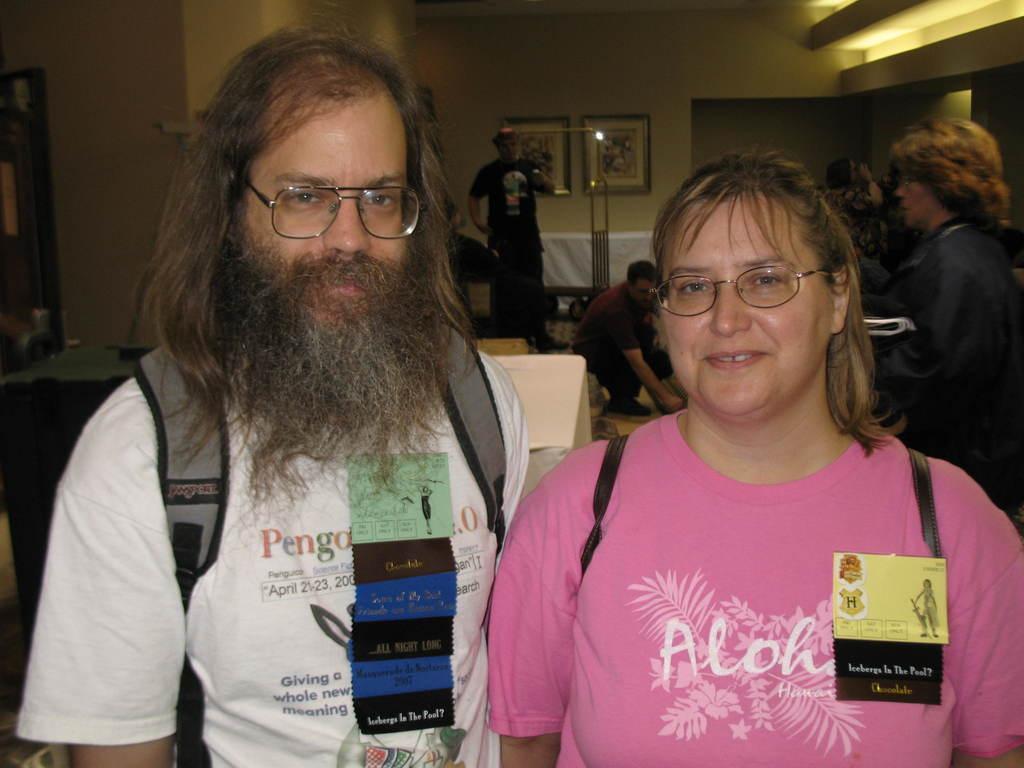In one or two sentences, can you explain what this image depicts? In the foreground of this image, there is a woman and a man wearing backpacks and also there are posters on them. Behind them, it seems like a table and an object on the wall. In the background, there are people, lights, wall, frames and few objects. 